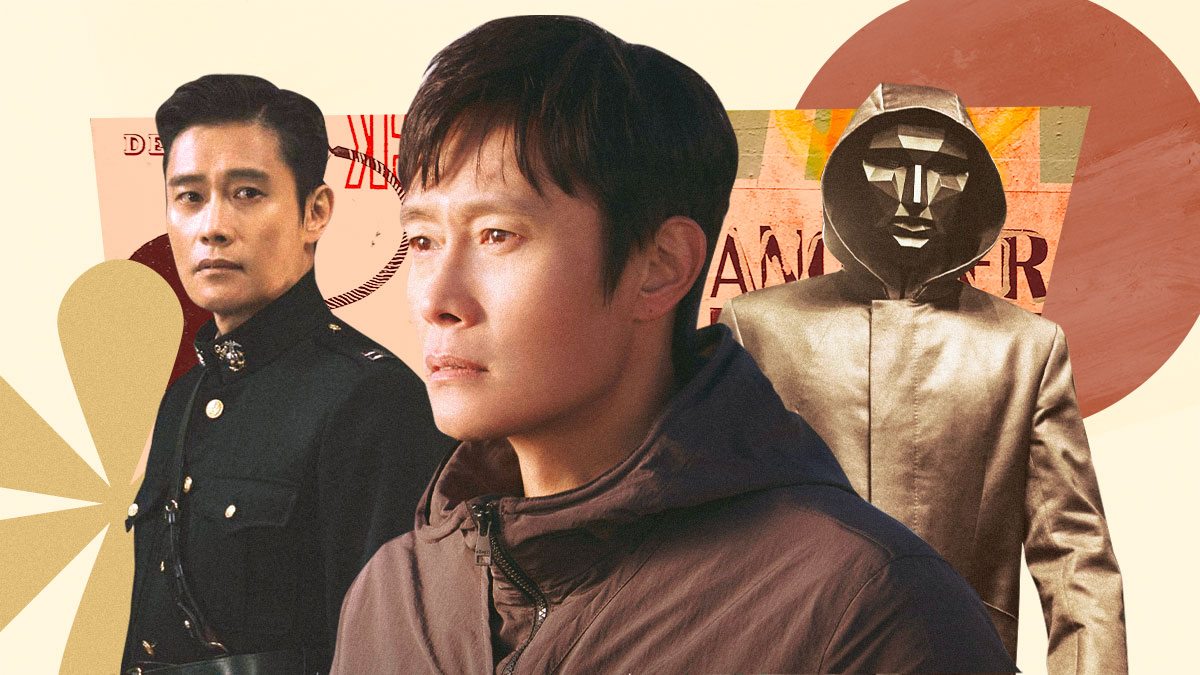Describe a day in the life of the character in the center. A day in the life of the character in the center—who appears thoughtful and serious in a brown jacket—might start with him waking up in a modest apartment, the walls lined with books and personal mementos. He spends his morning preparing a simple breakfast and reading the news, trying to stay informed. His afternoons are often spent in quiet contemplation, perhaps at a local park or a café, where he writes in his journal or sketches ideas. In the evening, he attends to his duties, which might be creative in nature, such as working on a screenplay or coordinating a community project. His demeanor suggests introspection and a quest for meaning, making his interactions thoughtful and deliberate. What kind of emotions do you think he struggles with most often? He likely struggles with emotions such as loneliness, uncertainty, and the weight of responsibility. His serious expression indicates that he is often deep in thought, perhaps grappling with decisions or past actions. He might also be navigating feelings of regret or seeking redemption, trying to find a balance between personal desires and societal expectations. His quiet demeanor suggests a reserved nature, possibly hinting at past traumas or missed opportunities that he continuously reflects upon. 